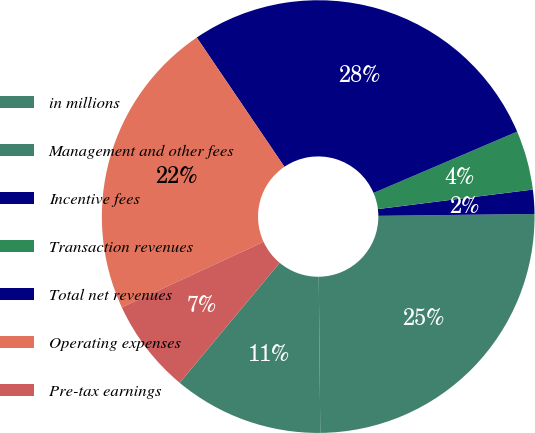<chart> <loc_0><loc_0><loc_500><loc_500><pie_chart><fcel>in millions<fcel>Management and other fees<fcel>Incentive fees<fcel>Transaction revenues<fcel>Total net revenues<fcel>Operating expenses<fcel>Pre-tax earnings<nl><fcel>11.21%<fcel>25.04%<fcel>1.8%<fcel>4.43%<fcel>28.06%<fcel>22.41%<fcel>7.05%<nl></chart> 